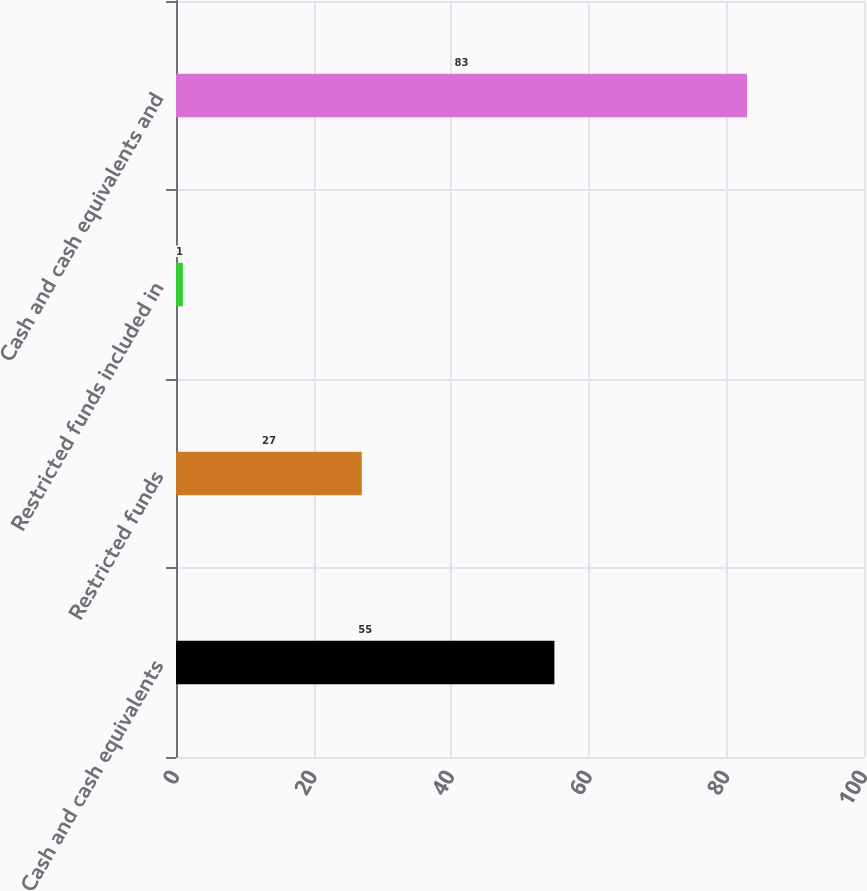Convert chart. <chart><loc_0><loc_0><loc_500><loc_500><bar_chart><fcel>Cash and cash equivalents<fcel>Restricted funds<fcel>Restricted funds included in<fcel>Cash and cash equivalents and<nl><fcel>55<fcel>27<fcel>1<fcel>83<nl></chart> 